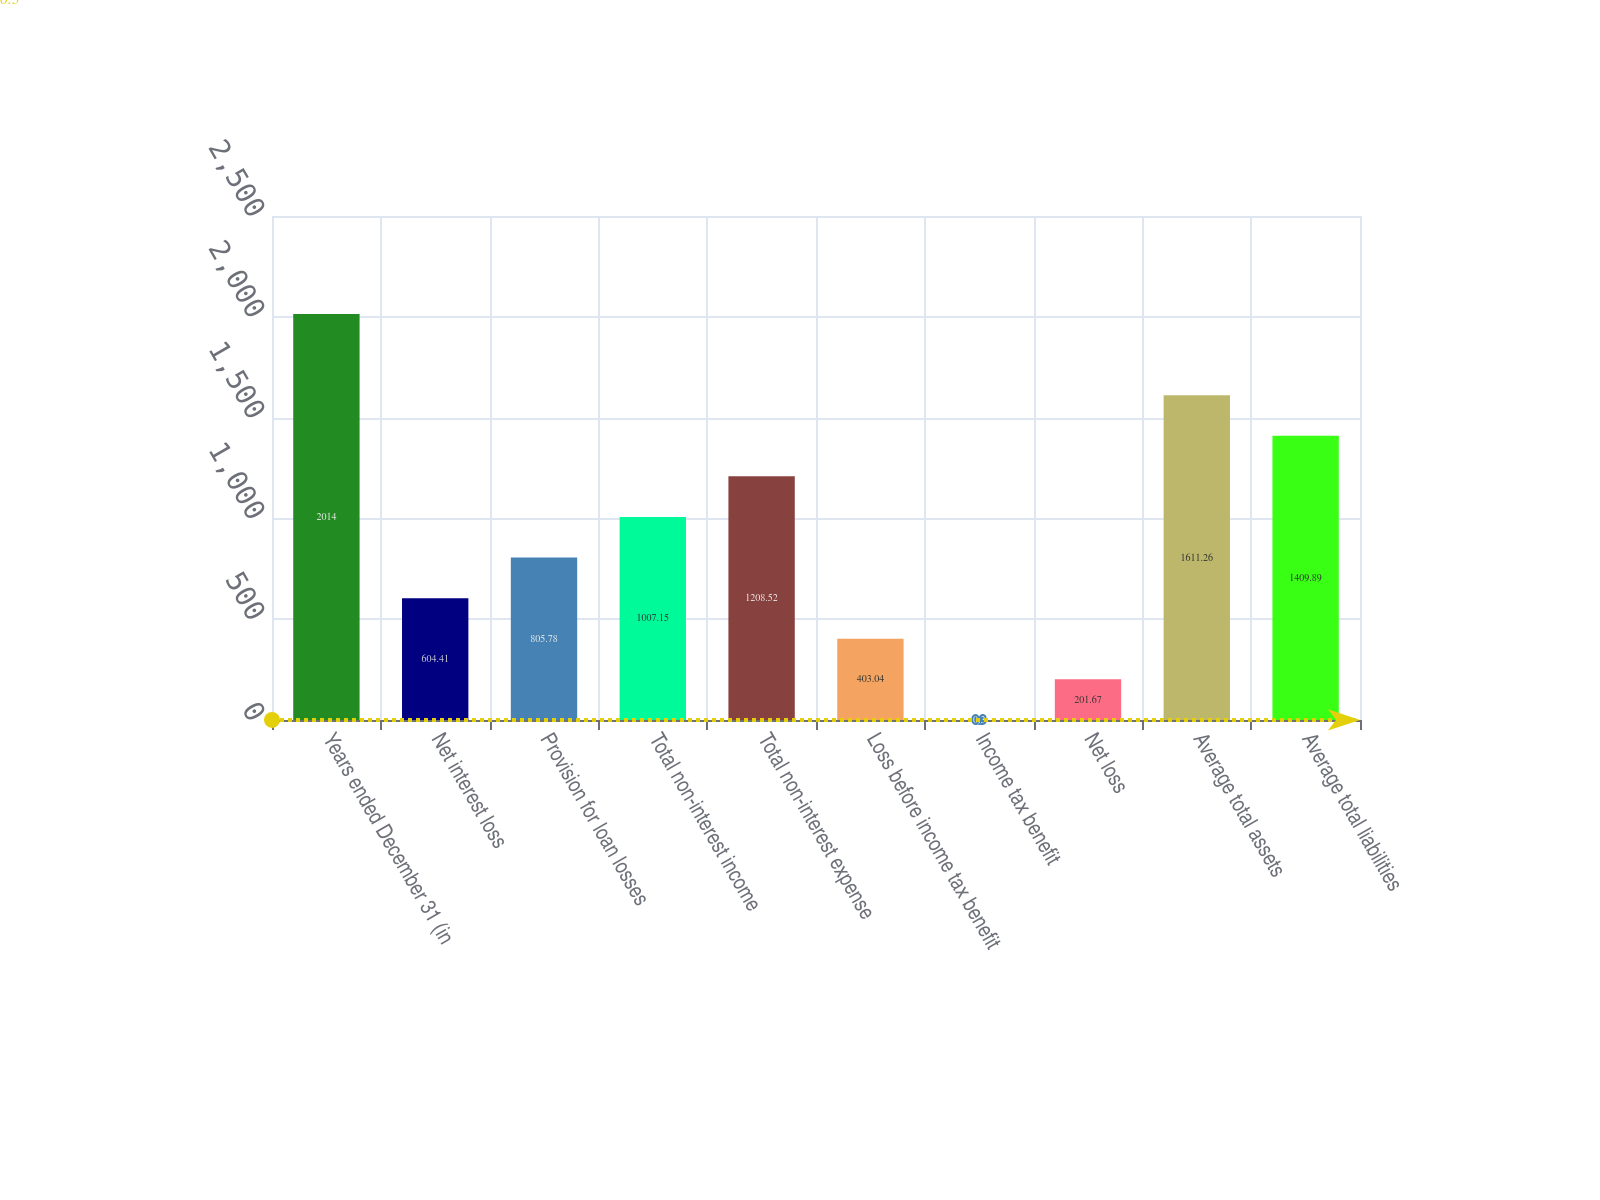<chart> <loc_0><loc_0><loc_500><loc_500><bar_chart><fcel>Years ended December 31 (in<fcel>Net interest loss<fcel>Provision for loan losses<fcel>Total non-interest income<fcel>Total non-interest expense<fcel>Loss before income tax benefit<fcel>Income tax benefit<fcel>Net loss<fcel>Average total assets<fcel>Average total liabilities<nl><fcel>2014<fcel>604.41<fcel>805.78<fcel>1007.15<fcel>1208.52<fcel>403.04<fcel>0.3<fcel>201.67<fcel>1611.26<fcel>1409.89<nl></chart> 